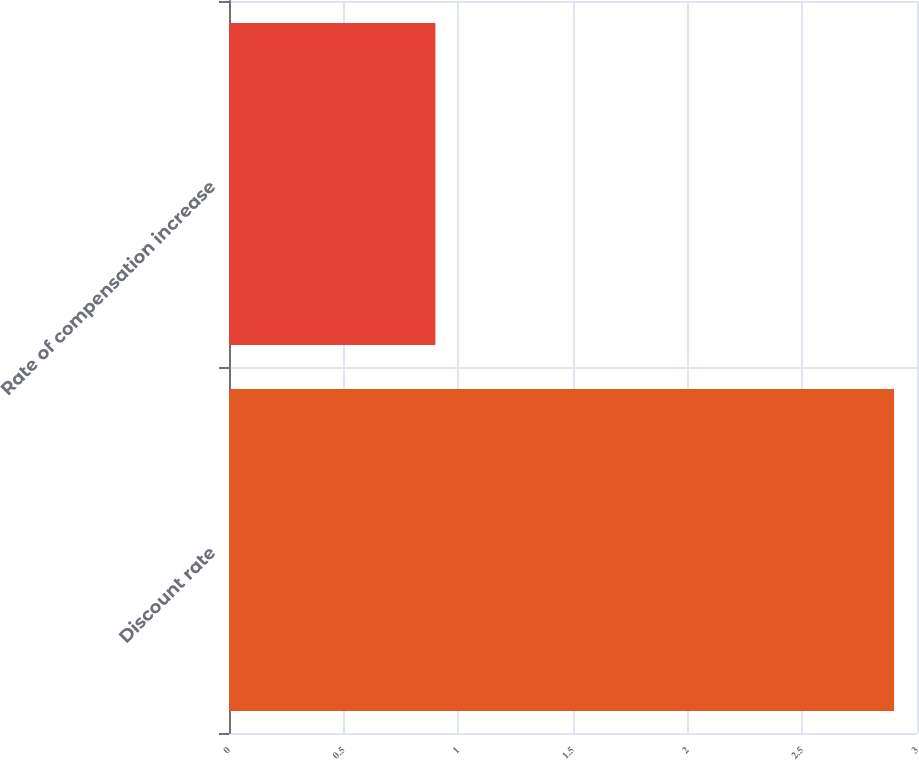<chart> <loc_0><loc_0><loc_500><loc_500><bar_chart><fcel>Discount rate<fcel>Rate of compensation increase<nl><fcel>2.9<fcel>0.9<nl></chart> 